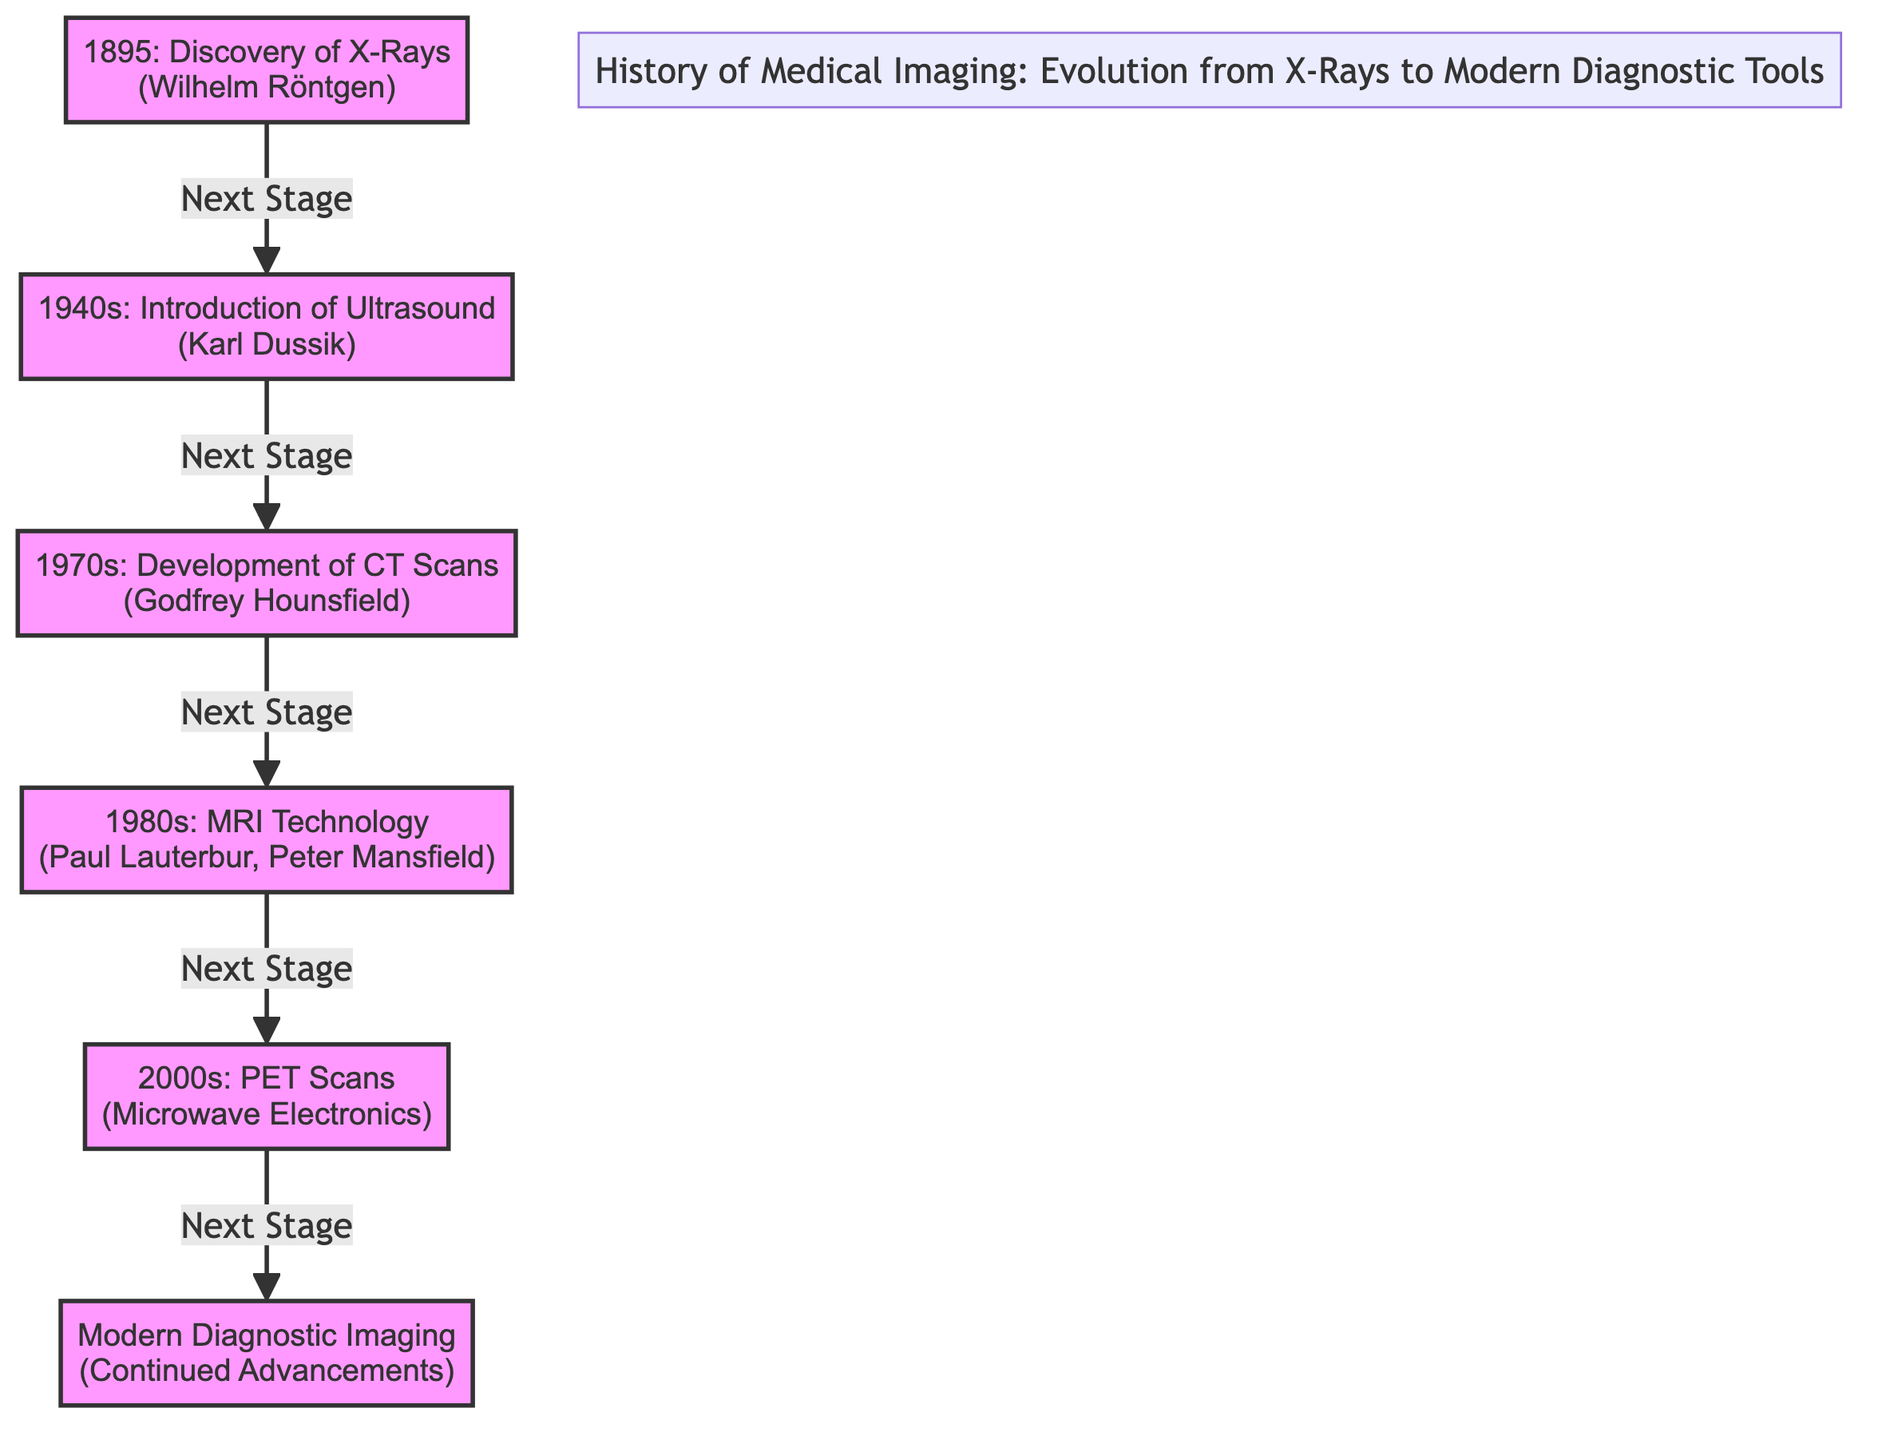What year was X-Rays discovered? X-Rays were discovered in 1895 according to the diagram.
Answer: 1895 Who was the pioneer behind the ultrasound introduction? The diagram indicates that Karl Dussik introduced ultrasound in the 1940s.
Answer: Karl Dussik What technology followed X-Rays in the evolution of medical imaging? The diagram shows that the next technology after X-Rays was ultrasound.
Answer: Ultrasound How many major milestones are shown in the diagram? The diagram displays five major milestones in the history of medical imaging.
Answer: 5 Which imaging technology was developed in the 1970s? According to the diagram, CT scans were developed in the 1970s.
Answer: CT Scans What is the last stage in the evolution of medical imaging shown in the diagram? The diagram indicates that the last stage is modern diagnostic imaging, which represents ongoing advancements.
Answer: Modern Diagnostic Imaging What decade did MRI technology emerge? The diagram shows that MRI technology emerged in the 1980s.
Answer: 1980s Which imaging technique came directly after MRI in the timeline? The diagram indicates that PET scans came directly after MRI in the timeline.
Answer: PET Scans Which two imaging technologies were developed in the 20th century? The diagram highlights that both ultrasound and CT scans were developed in the 20th century.
Answer: Ultrasound and CT Scans 